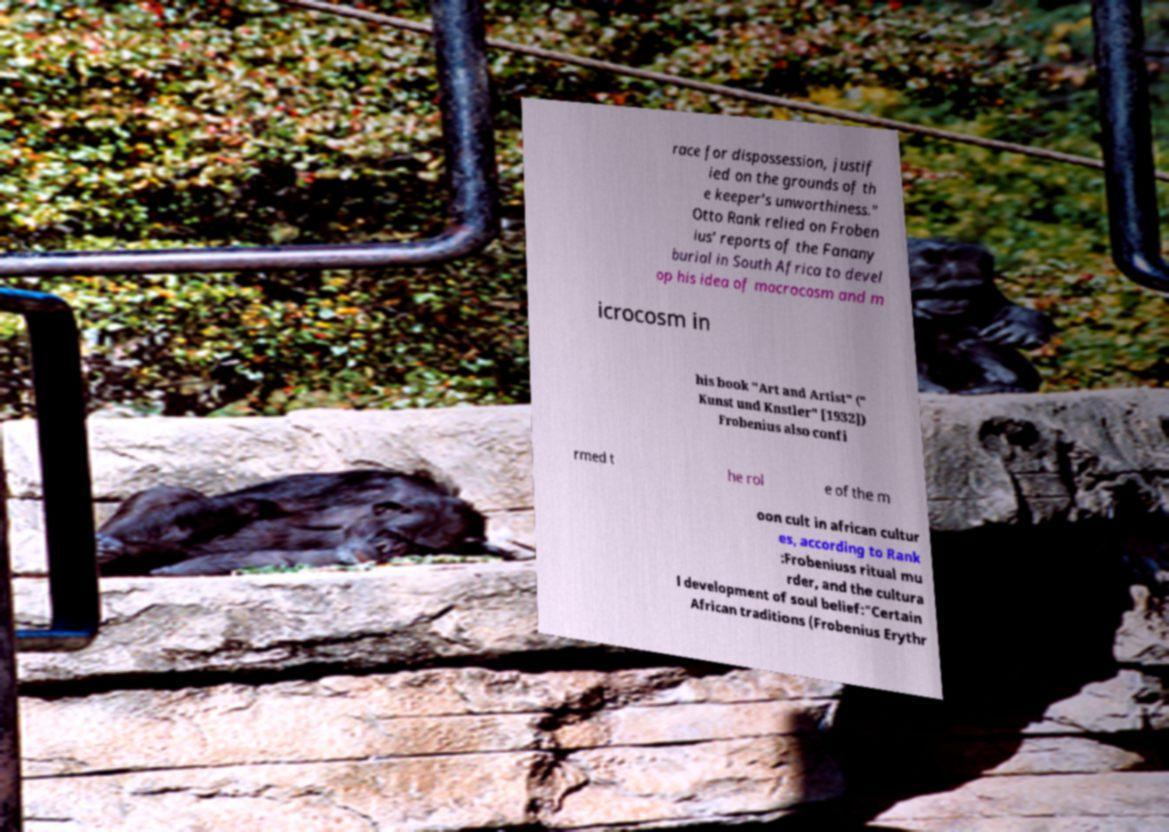Can you accurately transcribe the text from the provided image for me? race for dispossession, justif ied on the grounds of th e keeper's unworthiness." Otto Rank relied on Froben ius' reports of the Fanany burial in South Africa to devel op his idea of macrocosm and m icrocosm in his book "Art and Artist" (" Kunst und Knstler" [1932]) Frobenius also confi rmed t he rol e of the m oon cult in african cultur es, according to Rank :Frobeniuss ritual mu rder, and the cultura l development of soul belief:"Certain African traditions (Frobenius Erythr 